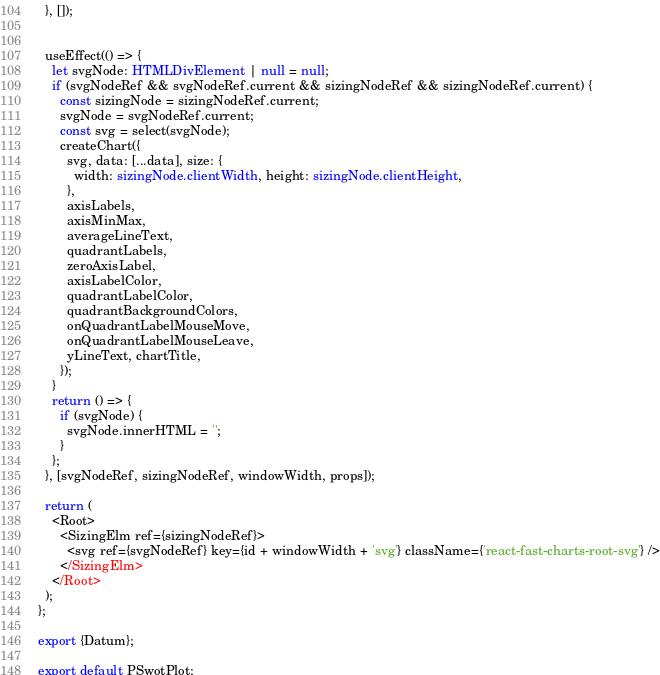Convert code to text. <code><loc_0><loc_0><loc_500><loc_500><_TypeScript_>  }, []);


  useEffect(() => {
    let svgNode: HTMLDivElement | null = null;
    if (svgNodeRef && svgNodeRef.current && sizingNodeRef && sizingNodeRef.current) {
      const sizingNode = sizingNodeRef.current;
      svgNode = svgNodeRef.current;
      const svg = select(svgNode);
      createChart({
        svg, data: [...data], size: {
          width: sizingNode.clientWidth, height: sizingNode.clientHeight,
        },
        axisLabels,
        axisMinMax,
        averageLineText,
        quadrantLabels,
        zeroAxisLabel,
        axisLabelColor,
        quadrantLabelColor,
        quadrantBackgroundColors,
        onQuadrantLabelMouseMove,
        onQuadrantLabelMouseLeave,
        yLineText, chartTitle,
      });
    }
    return () => {
      if (svgNode) {
        svgNode.innerHTML = '';
      }
    };
  }, [svgNodeRef, sizingNodeRef, windowWidth, props]);

  return (
    <Root>
      <SizingElm ref={sizingNodeRef}>
        <svg ref={svgNodeRef} key={id + windowWidth + 'svg'} className={'react-fast-charts-root-svg'} />
      </SizingElm>
    </Root>
  );
};

export {Datum};

export default PSwotPlot;
</code> 